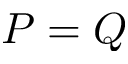<formula> <loc_0><loc_0><loc_500><loc_500>P = Q</formula> 